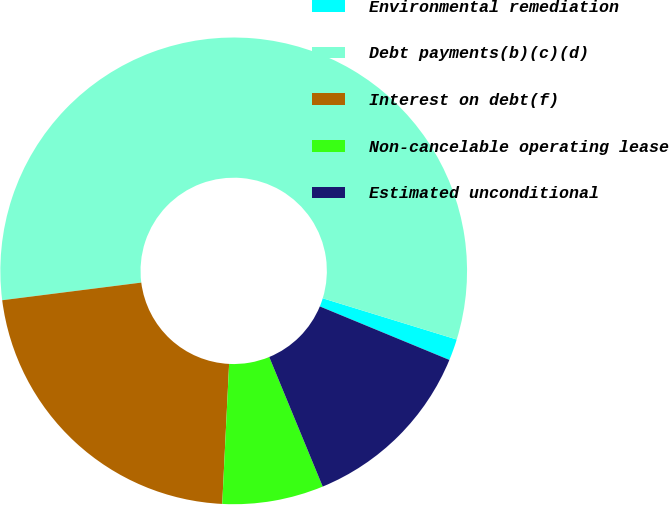<chart> <loc_0><loc_0><loc_500><loc_500><pie_chart><fcel>Environmental remediation<fcel>Debt payments(b)(c)(d)<fcel>Interest on debt(f)<fcel>Non-cancelable operating lease<fcel>Estimated unconditional<nl><fcel>1.48%<fcel>56.76%<fcel>22.21%<fcel>7.01%<fcel>12.54%<nl></chart> 